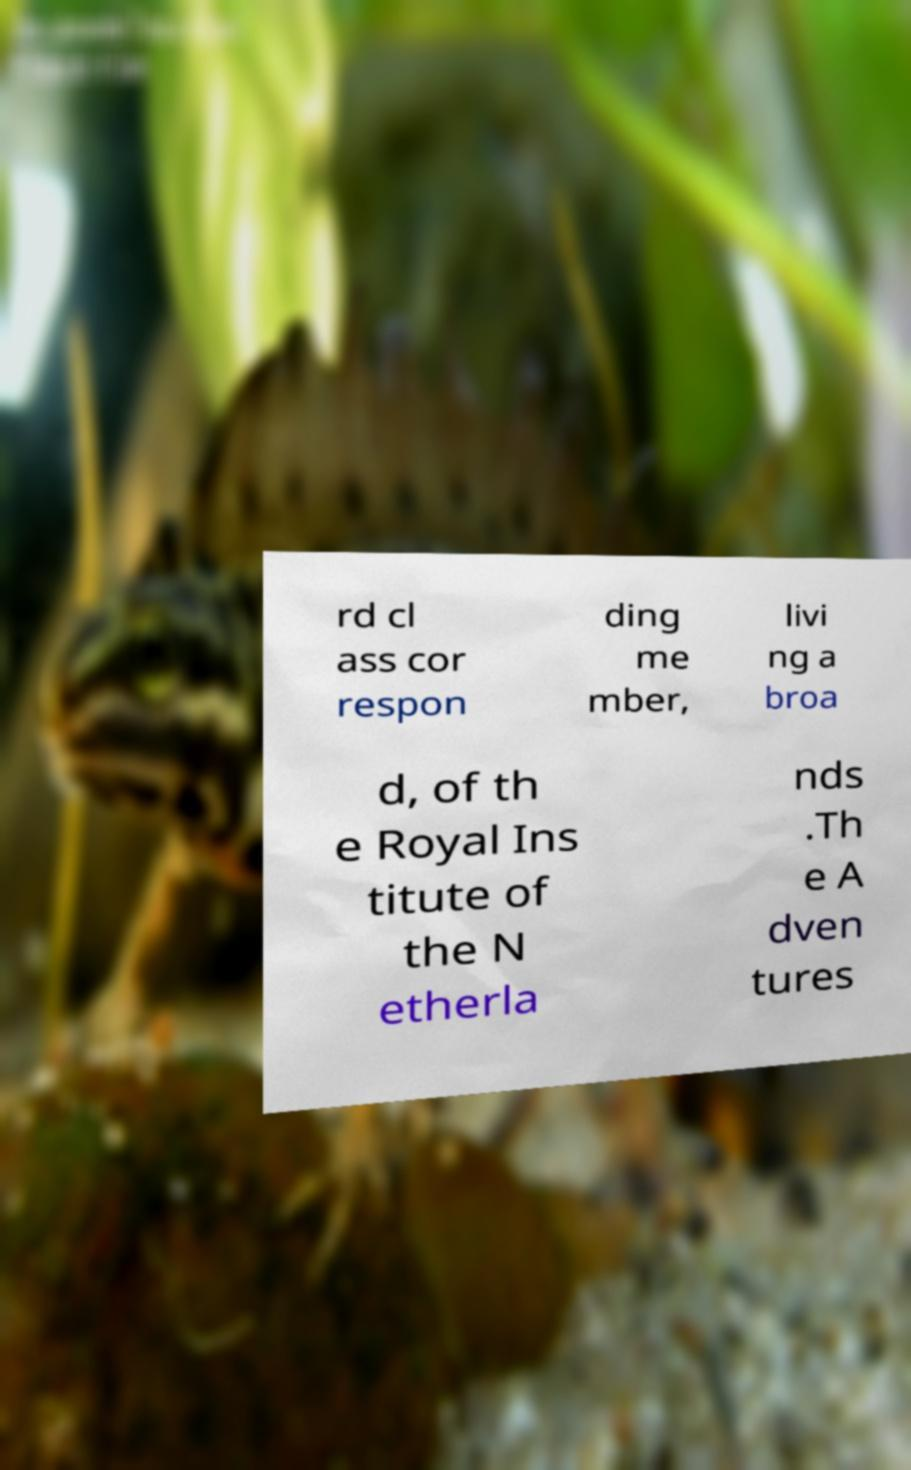There's text embedded in this image that I need extracted. Can you transcribe it verbatim? rd cl ass cor respon ding me mber, livi ng a broa d, of th e Royal Ins titute of the N etherla nds .Th e A dven tures 